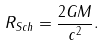Convert formula to latex. <formula><loc_0><loc_0><loc_500><loc_500>R _ { S c h } = \frac { 2 G M } { c ^ { 2 } } .</formula> 